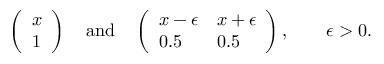<formula> <loc_0><loc_0><loc_500><loc_500>\left ( \begin{array} { l } { x } \\ { 1 } \end{array} \right ) \quad a n d \quad \left ( \begin{array} { l l } { x - \epsilon } & { x + \epsilon } \\ { 0 . 5 } & { 0 . 5 } \end{array} \right ) , \quad \epsilon > 0 .</formula> 